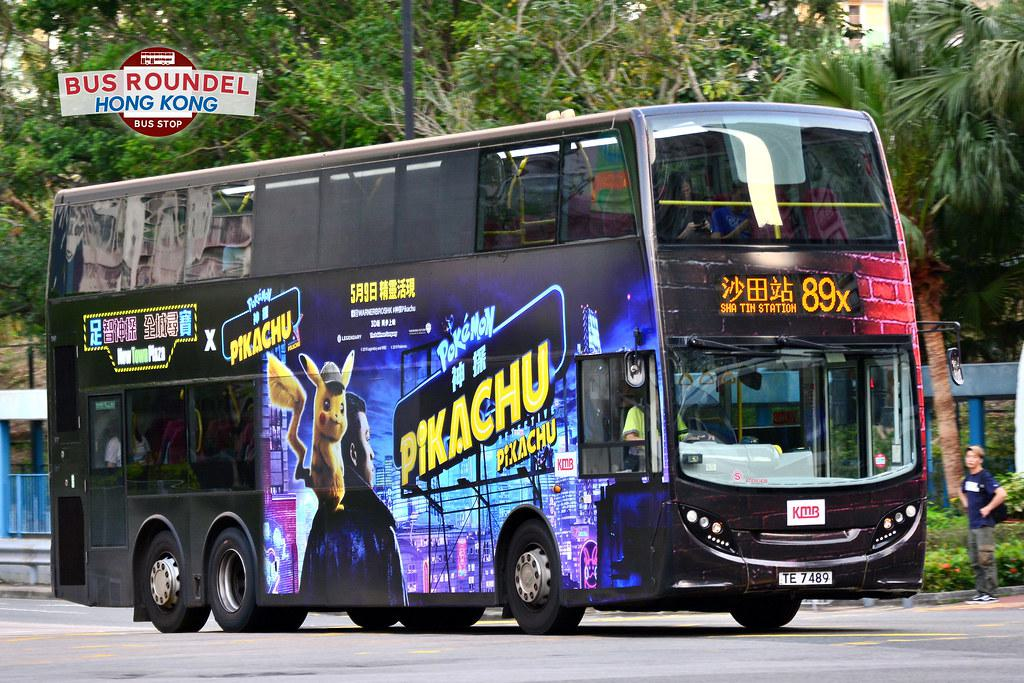What can be inferred about the location from the image? The image includes text in both English and Chinese, as well as the term 'KMB,' which stands for Kowloon Motor Bus, suggesting that this photograph was taken in Hong Kong. Additionally, the bus stop sign with the words 'BUS ROUNDEL HONG KONG' confirms the location. 